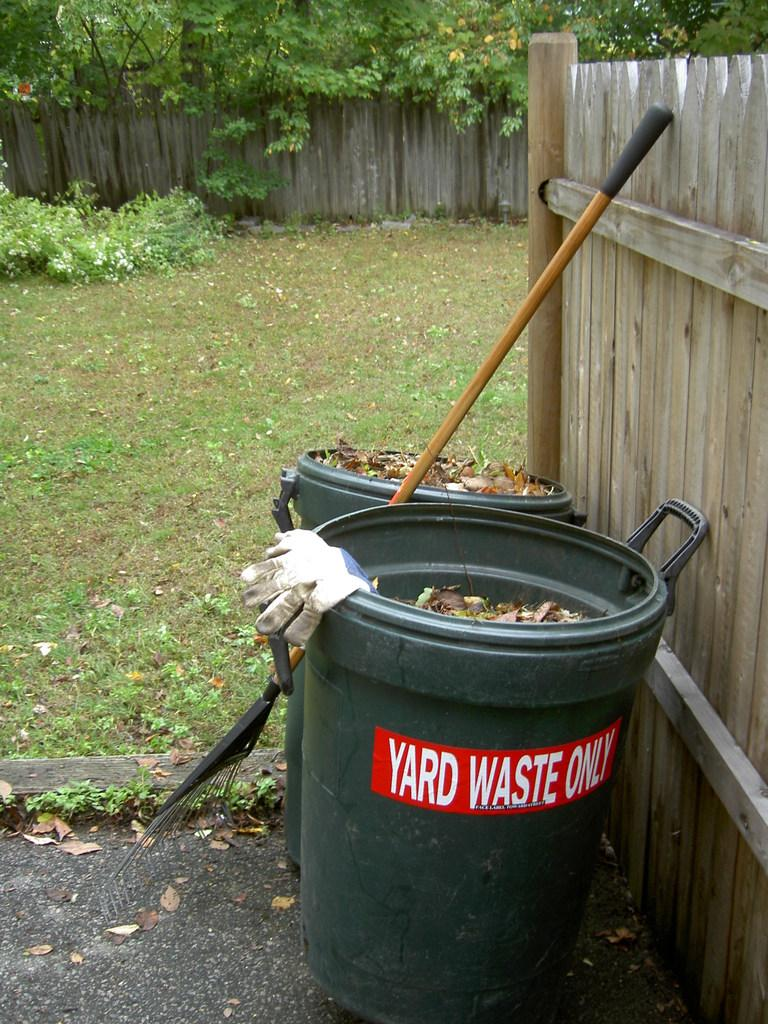<image>
Create a compact narrative representing the image presented. A green bin in next to a fence is labelled "yard waste only". 